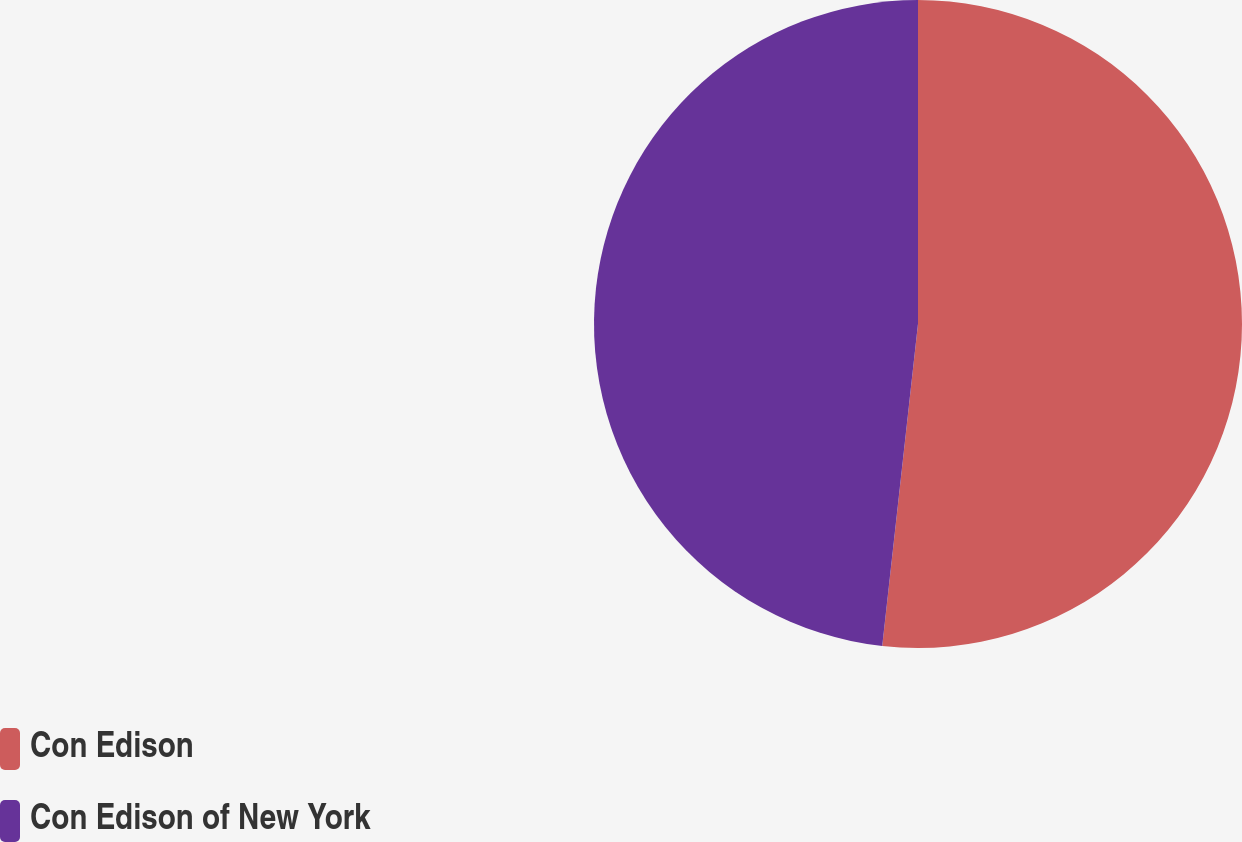Convert chart. <chart><loc_0><loc_0><loc_500><loc_500><pie_chart><fcel>Con Edison<fcel>Con Edison of New York<nl><fcel>51.76%<fcel>48.24%<nl></chart> 